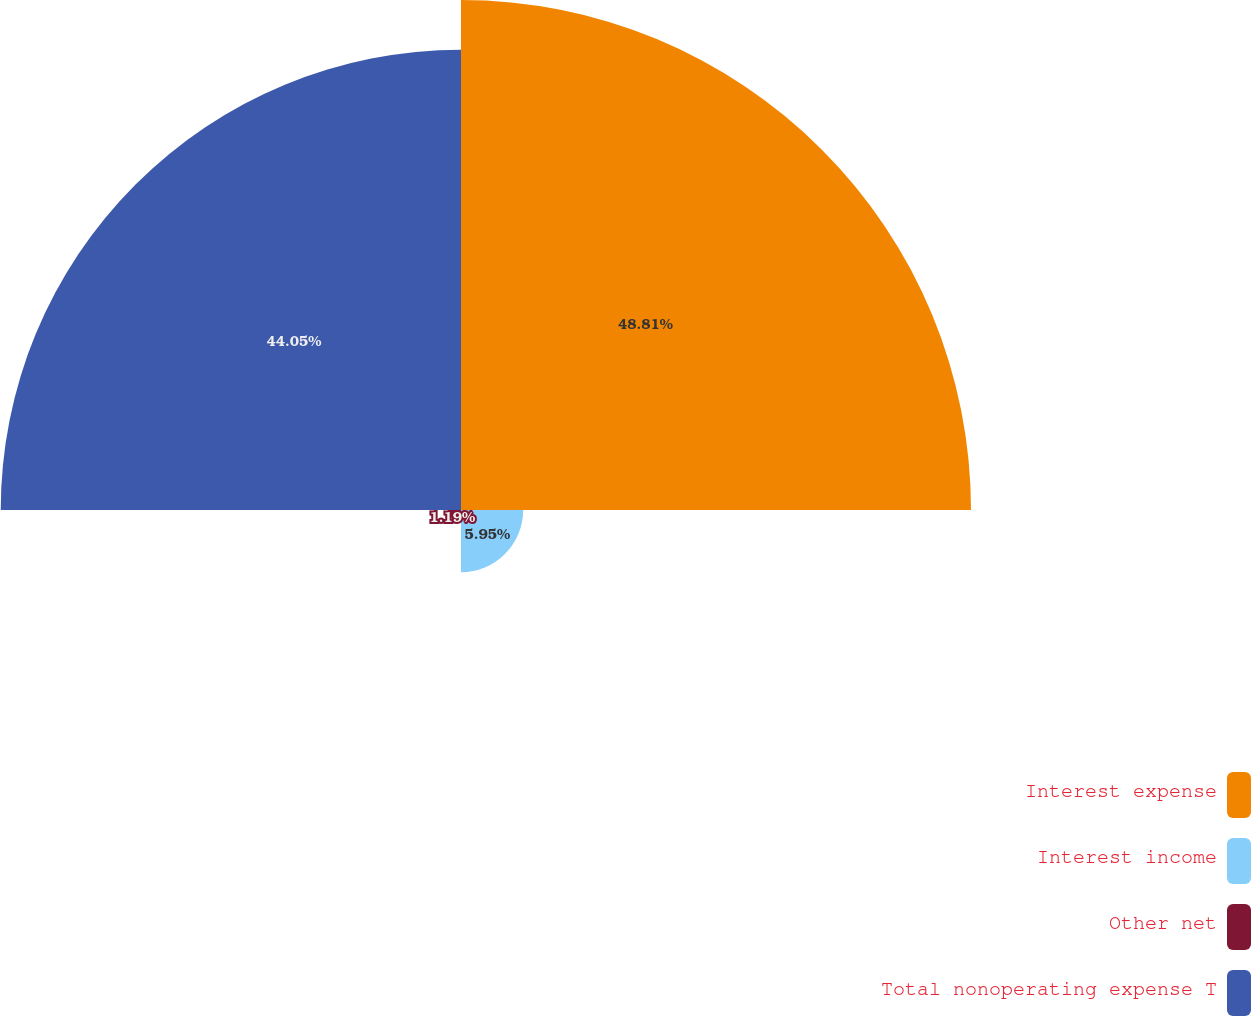Convert chart to OTSL. <chart><loc_0><loc_0><loc_500><loc_500><pie_chart><fcel>Interest expense<fcel>Interest income<fcel>Other net<fcel>Total nonoperating expense T<nl><fcel>48.81%<fcel>5.95%<fcel>1.19%<fcel>44.05%<nl></chart> 